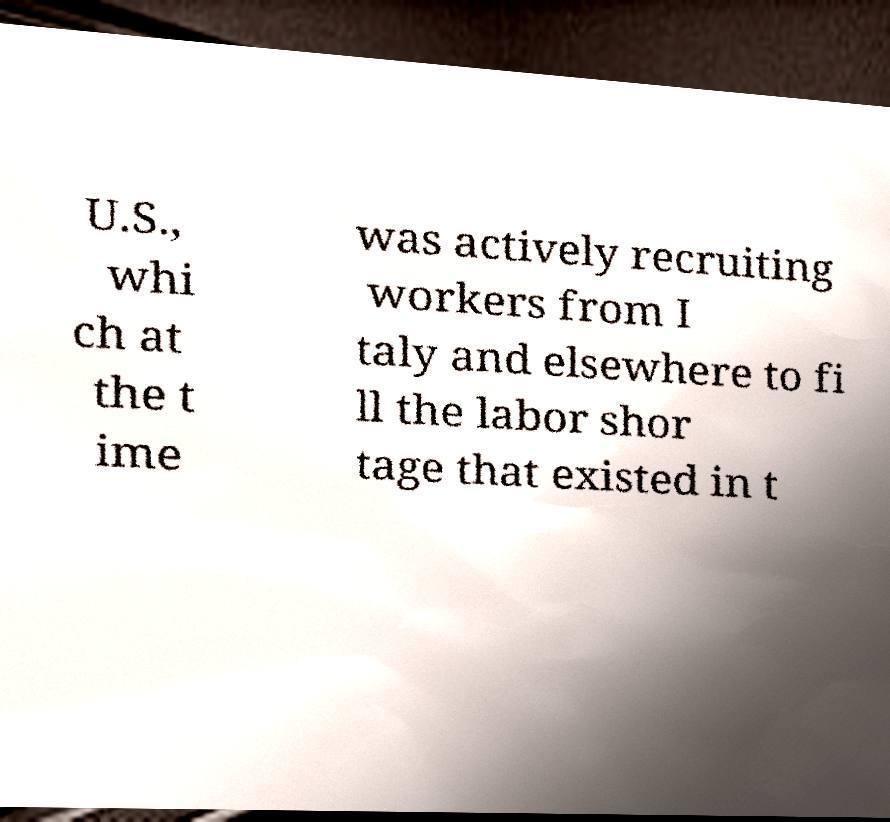Please identify and transcribe the text found in this image. U.S., whi ch at the t ime was actively recruiting workers from I taly and elsewhere to fi ll the labor shor tage that existed in t 